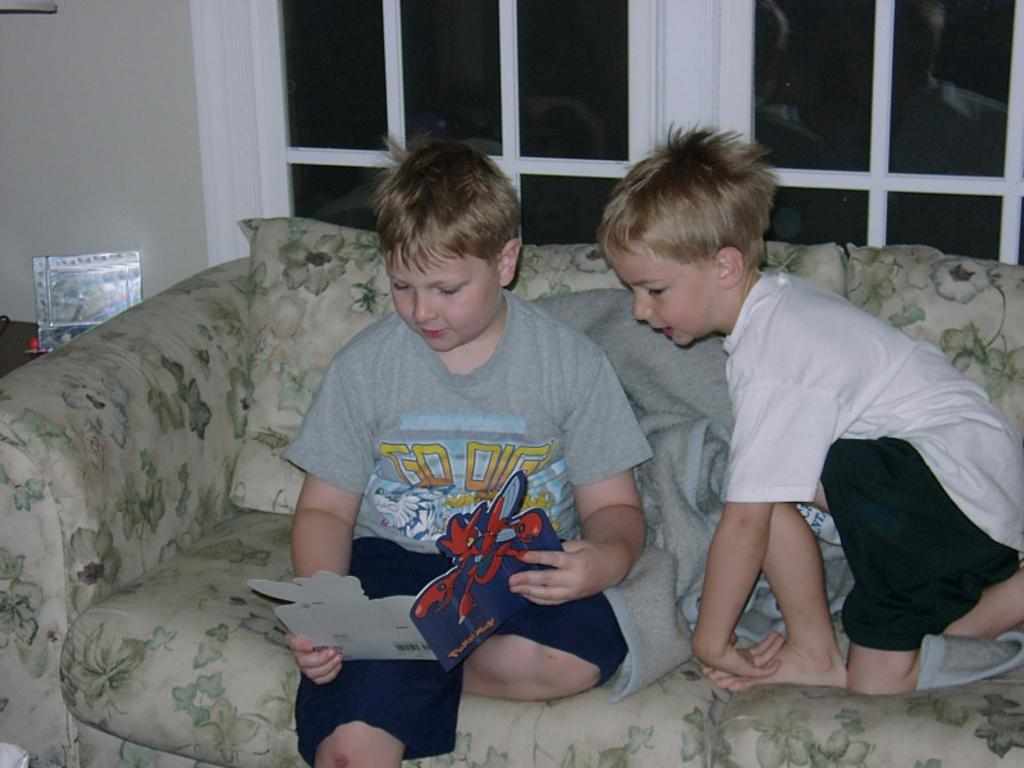How many people are in the image? There are two boys in the image. What are the boys doing in the image? The boys are sitting on a couch. What activity is one of the boys engaged in? One of the boys is reading a book. Can you describe the object on the table in the image? Unfortunately, the facts provided do not give any information about the object on the table. What type of fan is visible in the image? There is no fan present in the image. What fact can be learned about the floor in the image? There is no information about the floor in the image, so no fact can be learned about it. 